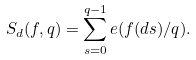<formula> <loc_0><loc_0><loc_500><loc_500>S _ { d } ( f , q ) = \sum _ { s = 0 } ^ { q - 1 } e ( f ( d s ) / q ) .</formula> 